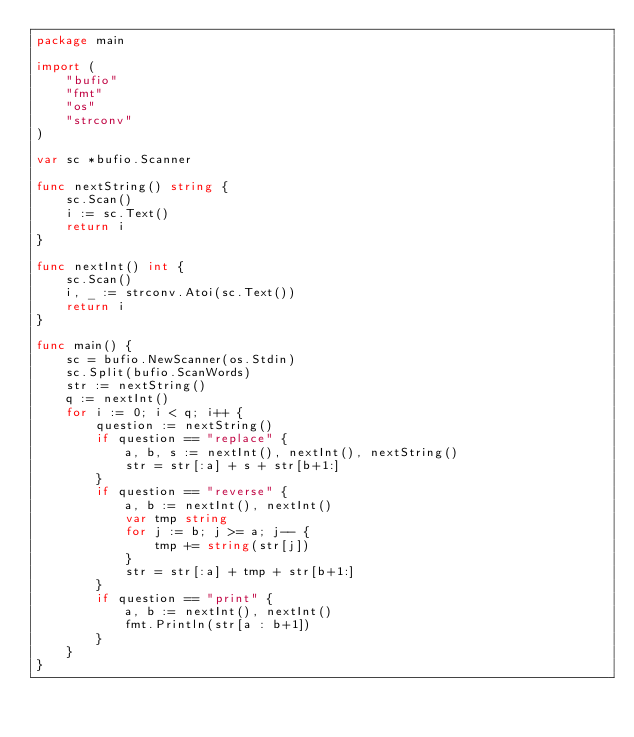Convert code to text. <code><loc_0><loc_0><loc_500><loc_500><_Go_>package main

import (
	"bufio"
	"fmt"
	"os"
	"strconv"
)

var sc *bufio.Scanner

func nextString() string {
	sc.Scan()
	i := sc.Text()
	return i
}

func nextInt() int {
	sc.Scan()
	i, _ := strconv.Atoi(sc.Text())
	return i
}

func main() {
	sc = bufio.NewScanner(os.Stdin)
	sc.Split(bufio.ScanWords)
	str := nextString()
	q := nextInt()
	for i := 0; i < q; i++ {
		question := nextString()
		if question == "replace" {
			a, b, s := nextInt(), nextInt(), nextString()
			str = str[:a] + s + str[b+1:]
		}
		if question == "reverse" {
			a, b := nextInt(), nextInt()
			var tmp string
			for j := b; j >= a; j-- {
				tmp += string(str[j])
			}
			str = str[:a] + tmp + str[b+1:]
		}
		if question == "print" {
			a, b := nextInt(), nextInt()
			fmt.Println(str[a : b+1])
		}
	}
}

</code> 